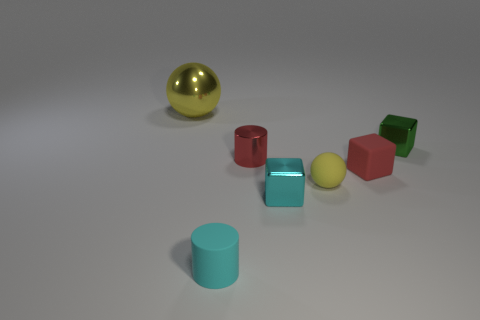Do the yellow ball that is on the right side of the red metal cylinder and the ball that is on the left side of the small matte cylinder have the same size?
Provide a short and direct response. No. What number of objects are cyan shiny cubes or small blocks that are in front of the small green shiny thing?
Your answer should be compact. 2. Are there any large gray things that have the same shape as the tiny red metallic thing?
Make the answer very short. No. How big is the metal block behind the cyan thing on the right side of the cyan cylinder?
Your answer should be very brief. Small. Is the large metal sphere the same color as the small matte block?
Keep it short and to the point. No. What number of matte objects are red cylinders or large yellow things?
Ensure brevity in your answer.  0. What number of big cyan spheres are there?
Give a very brief answer. 0. Are the ball that is in front of the large object and the small block that is on the left side of the red matte block made of the same material?
Provide a short and direct response. No. What is the color of the tiny rubber object that is the same shape as the big object?
Give a very brief answer. Yellow. What material is the yellow object behind the block that is behind the matte block?
Make the answer very short. Metal. 